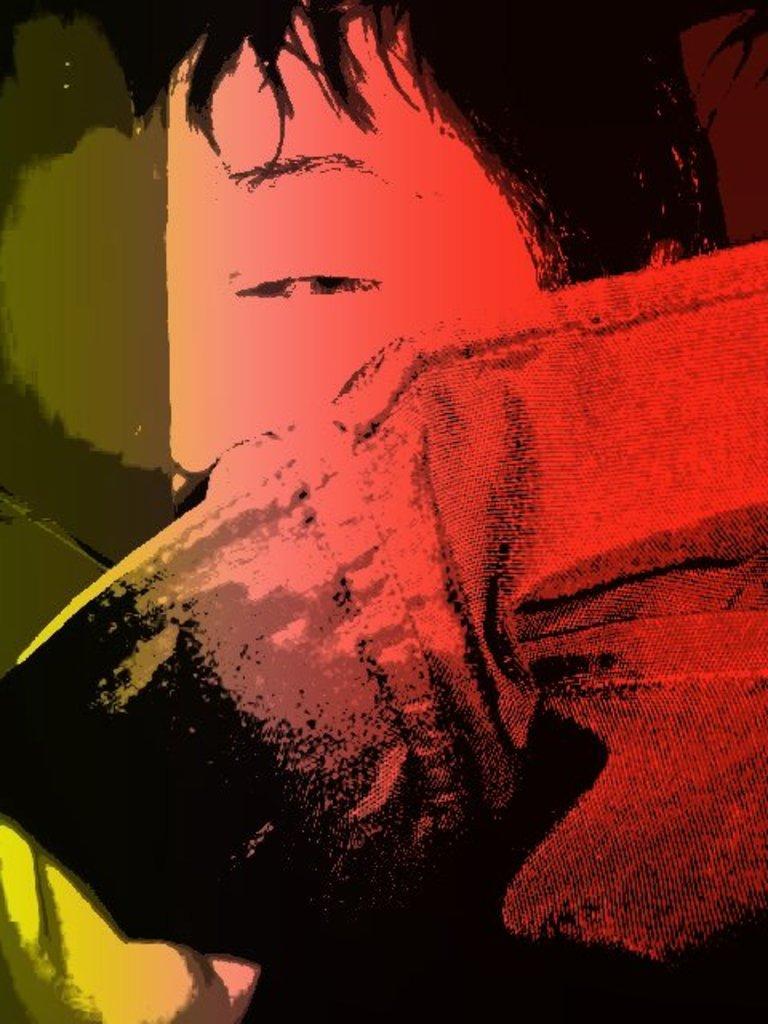Please provide a concise description of this image. In this picture I can see the painting of a man. 